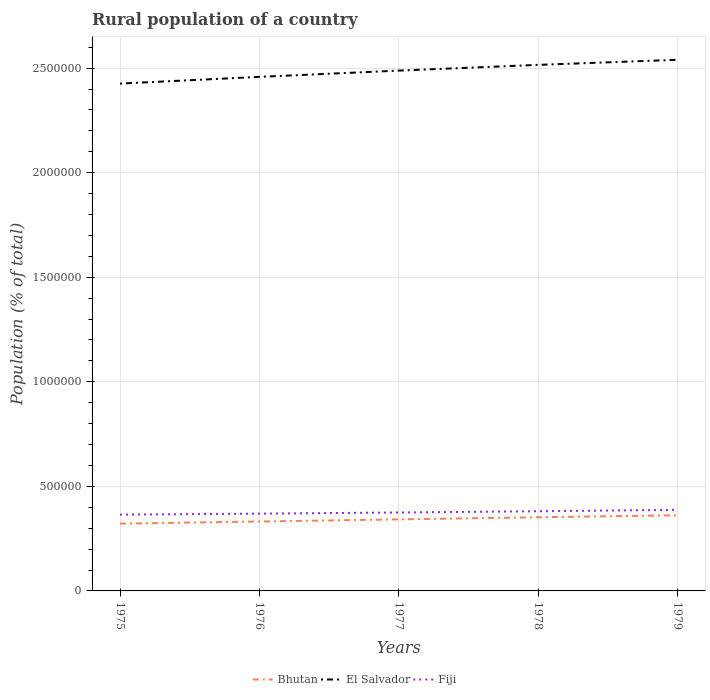Is the number of lines equal to the number of legend labels?
Your response must be concise. Yes. Across all years, what is the maximum rural population in Bhutan?
Provide a succinct answer. 3.22e+05. In which year was the rural population in Bhutan maximum?
Offer a very short reply. 1975. What is the total rural population in El Salvador in the graph?
Your answer should be very brief. -8.95e+04. What is the difference between the highest and the second highest rural population in El Salvador?
Your answer should be very brief. 1.14e+05. What is the difference between the highest and the lowest rural population in Bhutan?
Offer a very short reply. 3. How many lines are there?
Make the answer very short. 3. Are the values on the major ticks of Y-axis written in scientific E-notation?
Provide a short and direct response. No. Does the graph contain any zero values?
Offer a very short reply. No. How many legend labels are there?
Provide a succinct answer. 3. What is the title of the graph?
Your answer should be very brief. Rural population of a country. Does "St. Martin (French part)" appear as one of the legend labels in the graph?
Your answer should be compact. No. What is the label or title of the Y-axis?
Keep it short and to the point. Population (% of total). What is the Population (% of total) in Bhutan in 1975?
Make the answer very short. 3.22e+05. What is the Population (% of total) of El Salvador in 1975?
Your answer should be very brief. 2.43e+06. What is the Population (% of total) of Fiji in 1975?
Your response must be concise. 3.65e+05. What is the Population (% of total) in Bhutan in 1976?
Provide a succinct answer. 3.32e+05. What is the Population (% of total) of El Salvador in 1976?
Offer a terse response. 2.46e+06. What is the Population (% of total) of Fiji in 1976?
Make the answer very short. 3.69e+05. What is the Population (% of total) of Bhutan in 1977?
Provide a succinct answer. 3.42e+05. What is the Population (% of total) of El Salvador in 1977?
Provide a short and direct response. 2.49e+06. What is the Population (% of total) in Fiji in 1977?
Make the answer very short. 3.75e+05. What is the Population (% of total) in Bhutan in 1978?
Give a very brief answer. 3.52e+05. What is the Population (% of total) in El Salvador in 1978?
Give a very brief answer. 2.52e+06. What is the Population (% of total) of Fiji in 1978?
Keep it short and to the point. 3.81e+05. What is the Population (% of total) in Bhutan in 1979?
Your answer should be compact. 3.62e+05. What is the Population (% of total) of El Salvador in 1979?
Keep it short and to the point. 2.54e+06. What is the Population (% of total) of Fiji in 1979?
Your response must be concise. 3.88e+05. Across all years, what is the maximum Population (% of total) of Bhutan?
Offer a terse response. 3.62e+05. Across all years, what is the maximum Population (% of total) in El Salvador?
Offer a terse response. 2.54e+06. Across all years, what is the maximum Population (% of total) in Fiji?
Your response must be concise. 3.88e+05. Across all years, what is the minimum Population (% of total) of Bhutan?
Your response must be concise. 3.22e+05. Across all years, what is the minimum Population (% of total) of El Salvador?
Make the answer very short. 2.43e+06. Across all years, what is the minimum Population (% of total) in Fiji?
Your answer should be compact. 3.65e+05. What is the total Population (% of total) of Bhutan in the graph?
Your answer should be very brief. 1.71e+06. What is the total Population (% of total) of El Salvador in the graph?
Make the answer very short. 1.24e+07. What is the total Population (% of total) of Fiji in the graph?
Your response must be concise. 1.88e+06. What is the difference between the Population (% of total) of Bhutan in 1975 and that in 1976?
Provide a succinct answer. -1.02e+04. What is the difference between the Population (% of total) in El Salvador in 1975 and that in 1976?
Your answer should be compact. -3.21e+04. What is the difference between the Population (% of total) of Fiji in 1975 and that in 1976?
Offer a very short reply. -4578. What is the difference between the Population (% of total) in Bhutan in 1975 and that in 1977?
Your answer should be compact. -2.05e+04. What is the difference between the Population (% of total) of El Salvador in 1975 and that in 1977?
Offer a very short reply. -6.21e+04. What is the difference between the Population (% of total) in Fiji in 1975 and that in 1977?
Your answer should be compact. -1.01e+04. What is the difference between the Population (% of total) of Bhutan in 1975 and that in 1978?
Your answer should be compact. -3.05e+04. What is the difference between the Population (% of total) in El Salvador in 1975 and that in 1978?
Keep it short and to the point. -8.95e+04. What is the difference between the Population (% of total) of Fiji in 1975 and that in 1978?
Give a very brief answer. -1.62e+04. What is the difference between the Population (% of total) in Bhutan in 1975 and that in 1979?
Make the answer very short. -4.01e+04. What is the difference between the Population (% of total) of El Salvador in 1975 and that in 1979?
Provide a succinct answer. -1.14e+05. What is the difference between the Population (% of total) in Fiji in 1975 and that in 1979?
Your response must be concise. -2.29e+04. What is the difference between the Population (% of total) of Bhutan in 1976 and that in 1977?
Offer a very short reply. -1.03e+04. What is the difference between the Population (% of total) in El Salvador in 1976 and that in 1977?
Your response must be concise. -3.00e+04. What is the difference between the Population (% of total) of Fiji in 1976 and that in 1977?
Give a very brief answer. -5554. What is the difference between the Population (% of total) of Bhutan in 1976 and that in 1978?
Your answer should be compact. -2.03e+04. What is the difference between the Population (% of total) in El Salvador in 1976 and that in 1978?
Provide a succinct answer. -5.74e+04. What is the difference between the Population (% of total) of Fiji in 1976 and that in 1978?
Provide a succinct answer. -1.16e+04. What is the difference between the Population (% of total) in Bhutan in 1976 and that in 1979?
Provide a succinct answer. -2.99e+04. What is the difference between the Population (% of total) of El Salvador in 1976 and that in 1979?
Offer a very short reply. -8.18e+04. What is the difference between the Population (% of total) in Fiji in 1976 and that in 1979?
Ensure brevity in your answer.  -1.83e+04. What is the difference between the Population (% of total) in Bhutan in 1977 and that in 1978?
Offer a terse response. -1.01e+04. What is the difference between the Population (% of total) of El Salvador in 1977 and that in 1978?
Keep it short and to the point. -2.74e+04. What is the difference between the Population (% of total) in Fiji in 1977 and that in 1978?
Provide a succinct answer. -6037. What is the difference between the Population (% of total) of Bhutan in 1977 and that in 1979?
Provide a short and direct response. -1.97e+04. What is the difference between the Population (% of total) in El Salvador in 1977 and that in 1979?
Make the answer very short. -5.18e+04. What is the difference between the Population (% of total) of Fiji in 1977 and that in 1979?
Offer a very short reply. -1.27e+04. What is the difference between the Population (% of total) of Bhutan in 1978 and that in 1979?
Offer a very short reply. -9602. What is the difference between the Population (% of total) of El Salvador in 1978 and that in 1979?
Your answer should be compact. -2.44e+04. What is the difference between the Population (% of total) in Fiji in 1978 and that in 1979?
Make the answer very short. -6692. What is the difference between the Population (% of total) in Bhutan in 1975 and the Population (% of total) in El Salvador in 1976?
Offer a very short reply. -2.14e+06. What is the difference between the Population (% of total) in Bhutan in 1975 and the Population (% of total) in Fiji in 1976?
Make the answer very short. -4.78e+04. What is the difference between the Population (% of total) in El Salvador in 1975 and the Population (% of total) in Fiji in 1976?
Your answer should be very brief. 2.06e+06. What is the difference between the Population (% of total) of Bhutan in 1975 and the Population (% of total) of El Salvador in 1977?
Provide a short and direct response. -2.17e+06. What is the difference between the Population (% of total) in Bhutan in 1975 and the Population (% of total) in Fiji in 1977?
Make the answer very short. -5.33e+04. What is the difference between the Population (% of total) of El Salvador in 1975 and the Population (% of total) of Fiji in 1977?
Provide a succinct answer. 2.05e+06. What is the difference between the Population (% of total) of Bhutan in 1975 and the Population (% of total) of El Salvador in 1978?
Offer a terse response. -2.19e+06. What is the difference between the Population (% of total) in Bhutan in 1975 and the Population (% of total) in Fiji in 1978?
Your answer should be very brief. -5.94e+04. What is the difference between the Population (% of total) of El Salvador in 1975 and the Population (% of total) of Fiji in 1978?
Make the answer very short. 2.04e+06. What is the difference between the Population (% of total) in Bhutan in 1975 and the Population (% of total) in El Salvador in 1979?
Make the answer very short. -2.22e+06. What is the difference between the Population (% of total) of Bhutan in 1975 and the Population (% of total) of Fiji in 1979?
Offer a very short reply. -6.61e+04. What is the difference between the Population (% of total) of El Salvador in 1975 and the Population (% of total) of Fiji in 1979?
Your answer should be very brief. 2.04e+06. What is the difference between the Population (% of total) of Bhutan in 1976 and the Population (% of total) of El Salvador in 1977?
Provide a short and direct response. -2.16e+06. What is the difference between the Population (% of total) in Bhutan in 1976 and the Population (% of total) in Fiji in 1977?
Your response must be concise. -4.31e+04. What is the difference between the Population (% of total) in El Salvador in 1976 and the Population (% of total) in Fiji in 1977?
Ensure brevity in your answer.  2.08e+06. What is the difference between the Population (% of total) of Bhutan in 1976 and the Population (% of total) of El Salvador in 1978?
Your response must be concise. -2.18e+06. What is the difference between the Population (% of total) of Bhutan in 1976 and the Population (% of total) of Fiji in 1978?
Your answer should be compact. -4.92e+04. What is the difference between the Population (% of total) of El Salvador in 1976 and the Population (% of total) of Fiji in 1978?
Keep it short and to the point. 2.08e+06. What is the difference between the Population (% of total) in Bhutan in 1976 and the Population (% of total) in El Salvador in 1979?
Provide a succinct answer. -2.21e+06. What is the difference between the Population (% of total) in Bhutan in 1976 and the Population (% of total) in Fiji in 1979?
Offer a very short reply. -5.59e+04. What is the difference between the Population (% of total) of El Salvador in 1976 and the Population (% of total) of Fiji in 1979?
Keep it short and to the point. 2.07e+06. What is the difference between the Population (% of total) of Bhutan in 1977 and the Population (% of total) of El Salvador in 1978?
Your response must be concise. -2.17e+06. What is the difference between the Population (% of total) in Bhutan in 1977 and the Population (% of total) in Fiji in 1978?
Provide a succinct answer. -3.89e+04. What is the difference between the Population (% of total) of El Salvador in 1977 and the Population (% of total) of Fiji in 1978?
Your answer should be very brief. 2.11e+06. What is the difference between the Population (% of total) of Bhutan in 1977 and the Population (% of total) of El Salvador in 1979?
Give a very brief answer. -2.20e+06. What is the difference between the Population (% of total) in Bhutan in 1977 and the Population (% of total) in Fiji in 1979?
Offer a terse response. -4.56e+04. What is the difference between the Population (% of total) in El Salvador in 1977 and the Population (% of total) in Fiji in 1979?
Your answer should be compact. 2.10e+06. What is the difference between the Population (% of total) of Bhutan in 1978 and the Population (% of total) of El Salvador in 1979?
Your answer should be very brief. -2.19e+06. What is the difference between the Population (% of total) in Bhutan in 1978 and the Population (% of total) in Fiji in 1979?
Ensure brevity in your answer.  -3.55e+04. What is the difference between the Population (% of total) in El Salvador in 1978 and the Population (% of total) in Fiji in 1979?
Give a very brief answer. 2.13e+06. What is the average Population (% of total) of Bhutan per year?
Make the answer very short. 3.42e+05. What is the average Population (% of total) of El Salvador per year?
Your answer should be very brief. 2.49e+06. What is the average Population (% of total) of Fiji per year?
Offer a terse response. 3.76e+05. In the year 1975, what is the difference between the Population (% of total) in Bhutan and Population (% of total) in El Salvador?
Your response must be concise. -2.10e+06. In the year 1975, what is the difference between the Population (% of total) of Bhutan and Population (% of total) of Fiji?
Your answer should be compact. -4.32e+04. In the year 1975, what is the difference between the Population (% of total) of El Salvador and Population (% of total) of Fiji?
Your answer should be compact. 2.06e+06. In the year 1976, what is the difference between the Population (% of total) in Bhutan and Population (% of total) in El Salvador?
Give a very brief answer. -2.13e+06. In the year 1976, what is the difference between the Population (% of total) in Bhutan and Population (% of total) in Fiji?
Your answer should be compact. -3.76e+04. In the year 1976, what is the difference between the Population (% of total) in El Salvador and Population (% of total) in Fiji?
Keep it short and to the point. 2.09e+06. In the year 1977, what is the difference between the Population (% of total) of Bhutan and Population (% of total) of El Salvador?
Your response must be concise. -2.15e+06. In the year 1977, what is the difference between the Population (% of total) in Bhutan and Population (% of total) in Fiji?
Your response must be concise. -3.29e+04. In the year 1977, what is the difference between the Population (% of total) in El Salvador and Population (% of total) in Fiji?
Your response must be concise. 2.11e+06. In the year 1978, what is the difference between the Population (% of total) of Bhutan and Population (% of total) of El Salvador?
Ensure brevity in your answer.  -2.16e+06. In the year 1978, what is the difference between the Population (% of total) of Bhutan and Population (% of total) of Fiji?
Provide a succinct answer. -2.88e+04. In the year 1978, what is the difference between the Population (% of total) in El Salvador and Population (% of total) in Fiji?
Your response must be concise. 2.13e+06. In the year 1979, what is the difference between the Population (% of total) of Bhutan and Population (% of total) of El Salvador?
Keep it short and to the point. -2.18e+06. In the year 1979, what is the difference between the Population (% of total) in Bhutan and Population (% of total) in Fiji?
Provide a short and direct response. -2.59e+04. In the year 1979, what is the difference between the Population (% of total) in El Salvador and Population (% of total) in Fiji?
Make the answer very short. 2.15e+06. What is the ratio of the Population (% of total) in Bhutan in 1975 to that in 1976?
Offer a terse response. 0.97. What is the ratio of the Population (% of total) of El Salvador in 1975 to that in 1976?
Make the answer very short. 0.99. What is the ratio of the Population (% of total) in Fiji in 1975 to that in 1976?
Ensure brevity in your answer.  0.99. What is the ratio of the Population (% of total) in Bhutan in 1975 to that in 1977?
Provide a succinct answer. 0.94. What is the ratio of the Population (% of total) of Fiji in 1975 to that in 1977?
Your response must be concise. 0.97. What is the ratio of the Population (% of total) in Bhutan in 1975 to that in 1978?
Your answer should be compact. 0.91. What is the ratio of the Population (% of total) in El Salvador in 1975 to that in 1978?
Offer a very short reply. 0.96. What is the ratio of the Population (% of total) in Fiji in 1975 to that in 1978?
Your answer should be compact. 0.96. What is the ratio of the Population (% of total) in Bhutan in 1975 to that in 1979?
Keep it short and to the point. 0.89. What is the ratio of the Population (% of total) of El Salvador in 1975 to that in 1979?
Your response must be concise. 0.96. What is the ratio of the Population (% of total) in Fiji in 1975 to that in 1979?
Offer a very short reply. 0.94. What is the ratio of the Population (% of total) of Fiji in 1976 to that in 1977?
Your answer should be very brief. 0.99. What is the ratio of the Population (% of total) in Bhutan in 1976 to that in 1978?
Offer a very short reply. 0.94. What is the ratio of the Population (% of total) of El Salvador in 1976 to that in 1978?
Give a very brief answer. 0.98. What is the ratio of the Population (% of total) in Fiji in 1976 to that in 1978?
Give a very brief answer. 0.97. What is the ratio of the Population (% of total) of Bhutan in 1976 to that in 1979?
Offer a very short reply. 0.92. What is the ratio of the Population (% of total) of El Salvador in 1976 to that in 1979?
Your answer should be very brief. 0.97. What is the ratio of the Population (% of total) of Fiji in 1976 to that in 1979?
Provide a succinct answer. 0.95. What is the ratio of the Population (% of total) of Bhutan in 1977 to that in 1978?
Your response must be concise. 0.97. What is the ratio of the Population (% of total) in Fiji in 1977 to that in 1978?
Provide a succinct answer. 0.98. What is the ratio of the Population (% of total) of Bhutan in 1977 to that in 1979?
Your answer should be compact. 0.95. What is the ratio of the Population (% of total) in El Salvador in 1977 to that in 1979?
Make the answer very short. 0.98. What is the ratio of the Population (% of total) of Fiji in 1977 to that in 1979?
Your response must be concise. 0.97. What is the ratio of the Population (% of total) of Bhutan in 1978 to that in 1979?
Give a very brief answer. 0.97. What is the ratio of the Population (% of total) in El Salvador in 1978 to that in 1979?
Ensure brevity in your answer.  0.99. What is the ratio of the Population (% of total) in Fiji in 1978 to that in 1979?
Your answer should be very brief. 0.98. What is the difference between the highest and the second highest Population (% of total) of Bhutan?
Offer a terse response. 9602. What is the difference between the highest and the second highest Population (% of total) in El Salvador?
Your answer should be compact. 2.44e+04. What is the difference between the highest and the second highest Population (% of total) in Fiji?
Your answer should be compact. 6692. What is the difference between the highest and the lowest Population (% of total) of Bhutan?
Give a very brief answer. 4.01e+04. What is the difference between the highest and the lowest Population (% of total) of El Salvador?
Ensure brevity in your answer.  1.14e+05. What is the difference between the highest and the lowest Population (% of total) of Fiji?
Your answer should be very brief. 2.29e+04. 